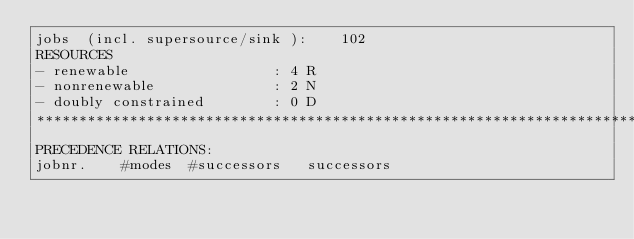Convert code to text. <code><loc_0><loc_0><loc_500><loc_500><_ObjectiveC_>jobs  (incl. supersource/sink ):	102
RESOURCES
- renewable                 : 4 R
- nonrenewable              : 2 N
- doubly constrained        : 0 D
************************************************************************
PRECEDENCE RELATIONS:
jobnr.    #modes  #successors   successors</code> 